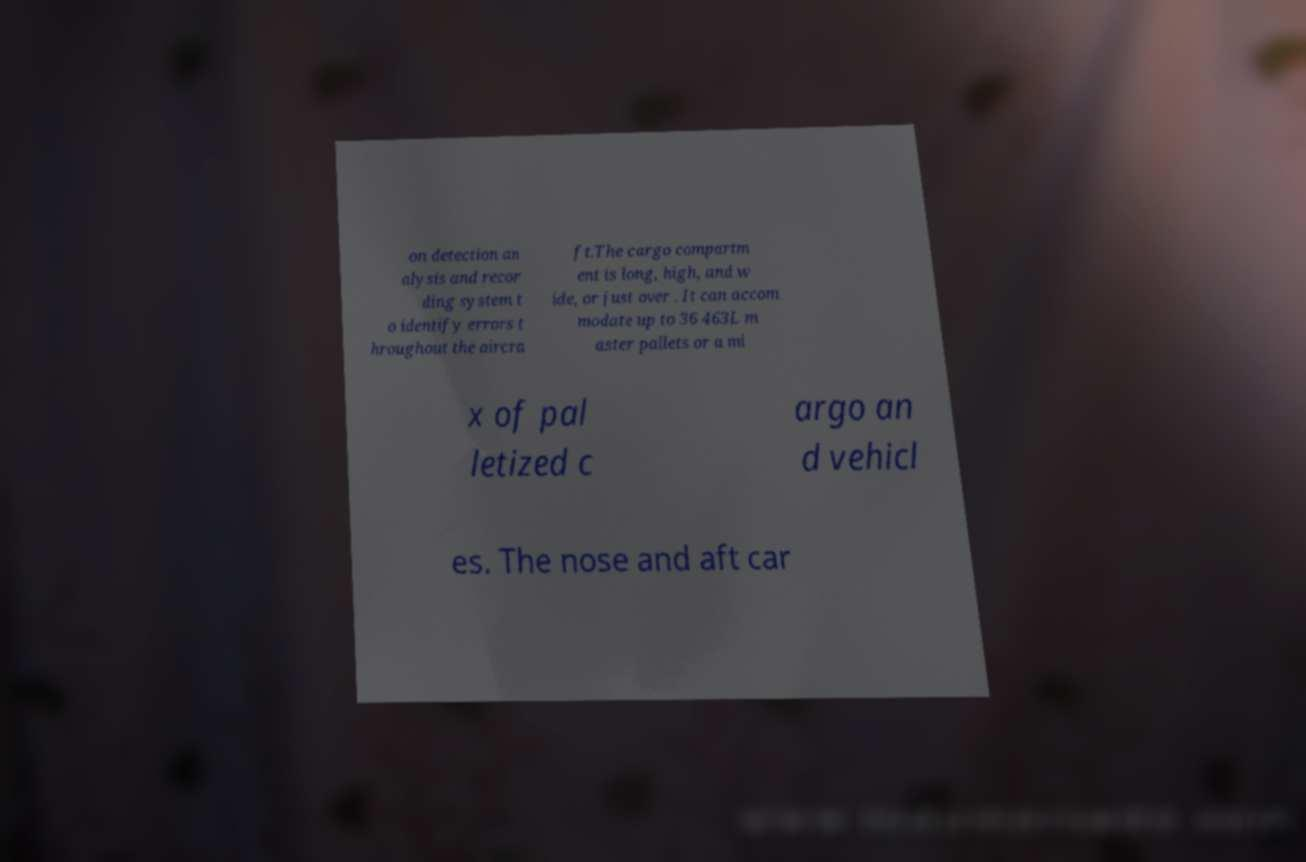There's text embedded in this image that I need extracted. Can you transcribe it verbatim? on detection an alysis and recor ding system t o identify errors t hroughout the aircra ft.The cargo compartm ent is long, high, and w ide, or just over . It can accom modate up to 36 463L m aster pallets or a mi x of pal letized c argo an d vehicl es. The nose and aft car 